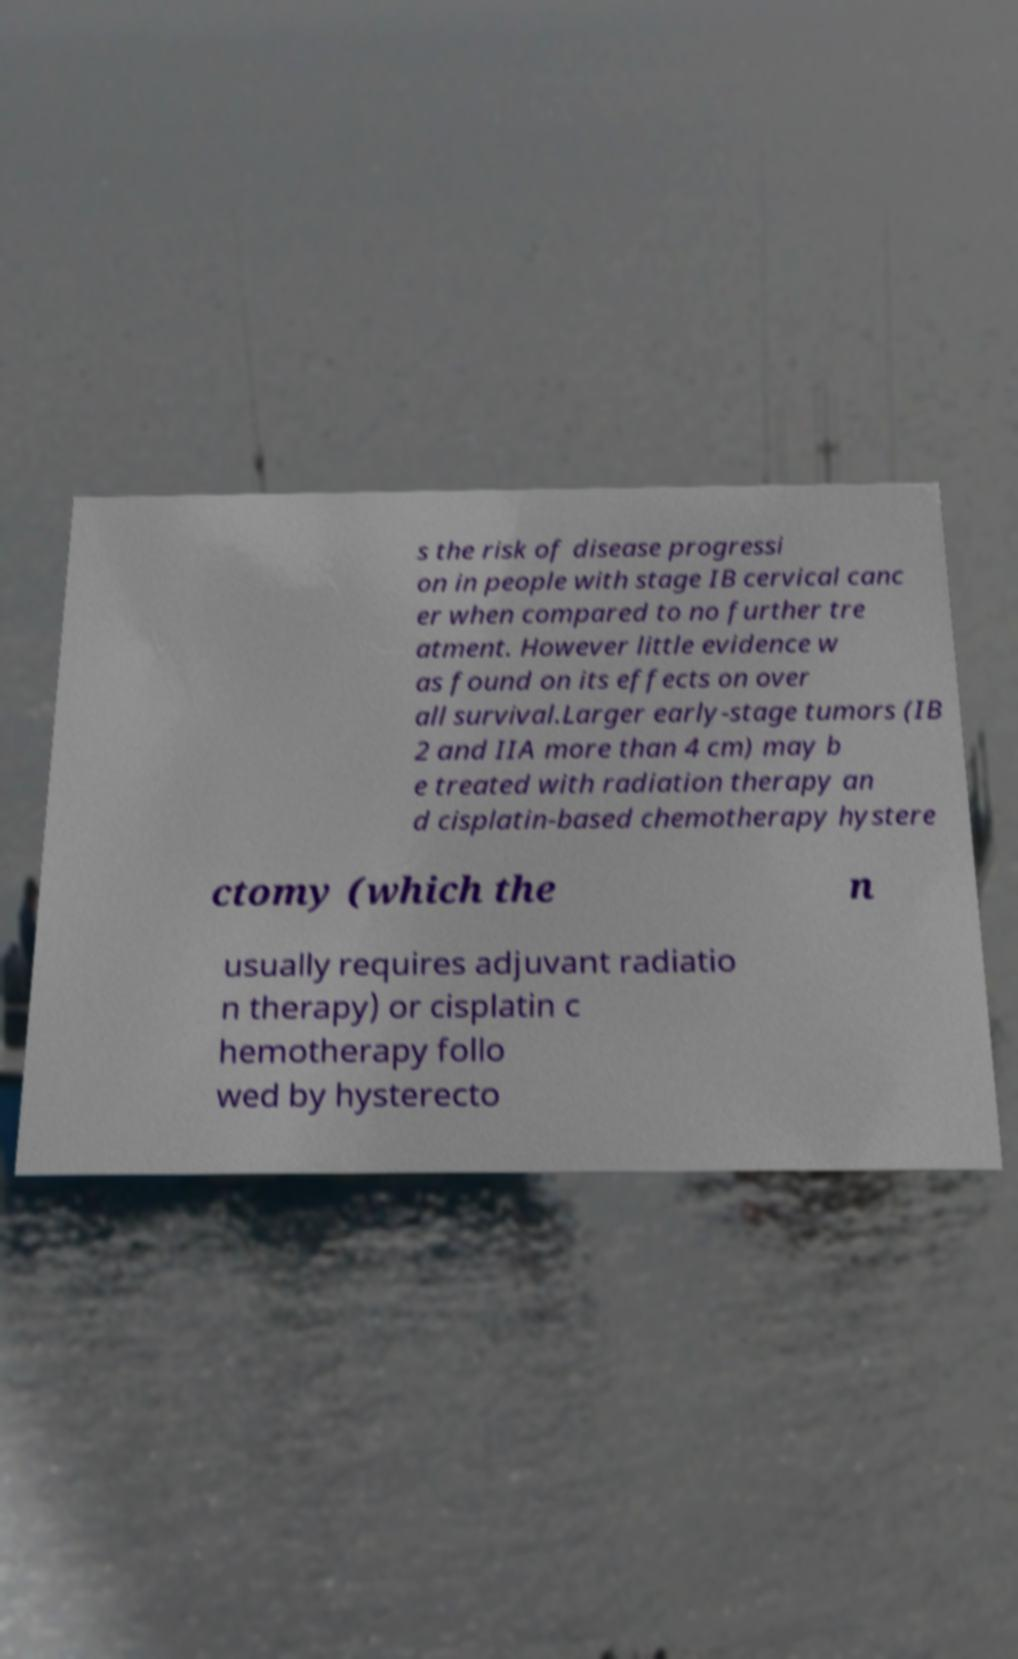Can you read and provide the text displayed in the image?This photo seems to have some interesting text. Can you extract and type it out for me? s the risk of disease progressi on in people with stage IB cervical canc er when compared to no further tre atment. However little evidence w as found on its effects on over all survival.Larger early-stage tumors (IB 2 and IIA more than 4 cm) may b e treated with radiation therapy an d cisplatin-based chemotherapy hystere ctomy (which the n usually requires adjuvant radiatio n therapy) or cisplatin c hemotherapy follo wed by hysterecto 